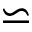<formula> <loc_0><loc_0><loc_500><loc_500>\backsimeq</formula> 